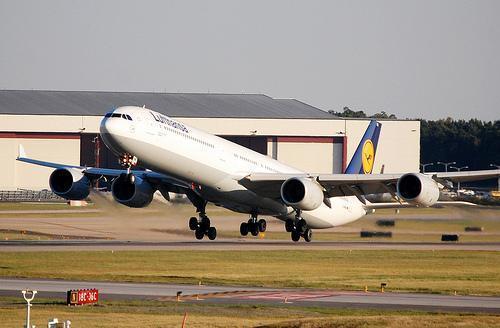How many engines are shown?
Give a very brief answer. 4. How many engines?
Give a very brief answer. 4. How many planes taking off?
Give a very brief answer. 1. How many airplanes are in the picture?
Give a very brief answer. 1. 